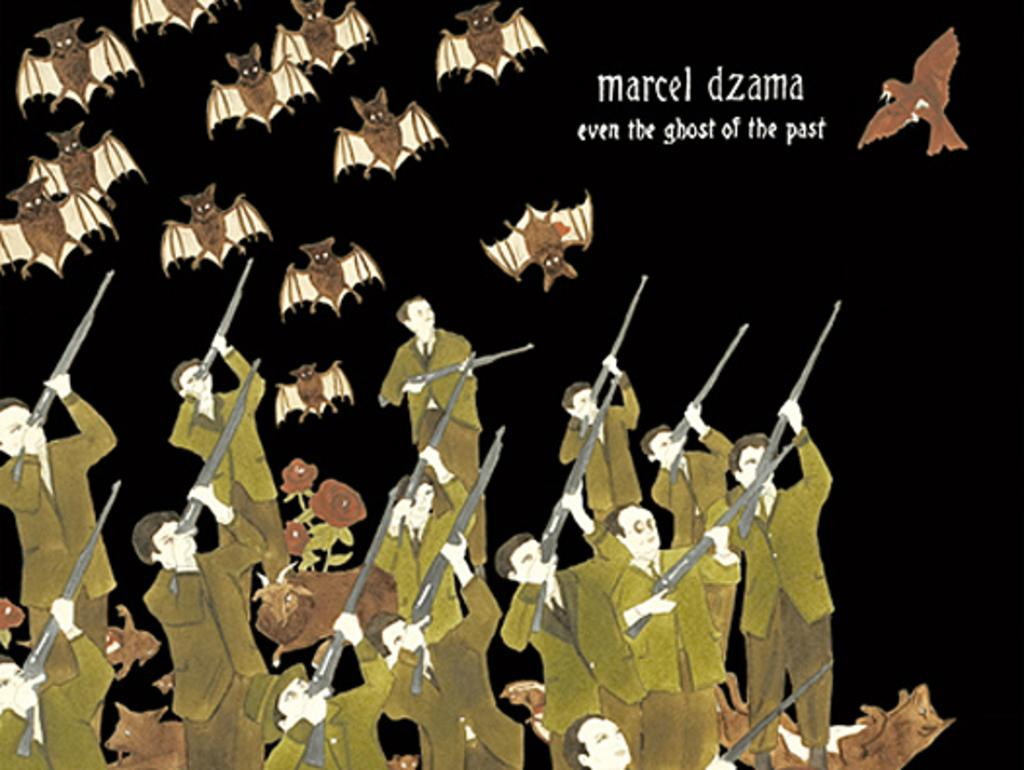What type of image is being described? The image is an animated picture. What are the people in the image doing? The people in the image are wearing clothes and holding rifles in their hands. What else can be seen in the image besides the people? There are many bats and a text in the image. Can you tell me how many people made a request in the image? There is no mention of any requests being made in the image. What type of person is depicted in the image? The image does not show any specific person; it features people in general. 